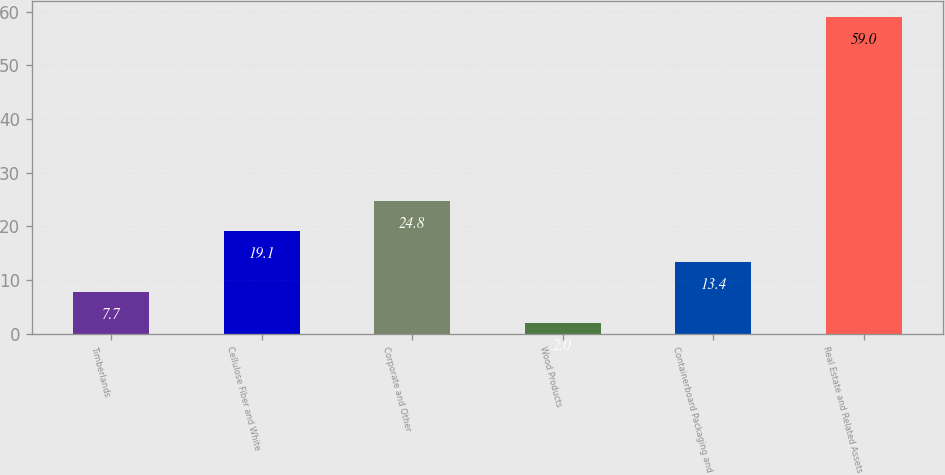Convert chart. <chart><loc_0><loc_0><loc_500><loc_500><bar_chart><fcel>Timberlands<fcel>Cellulose Fiber and White<fcel>Corporate and Other<fcel>Wood Products<fcel>Containerboard Packaging and<fcel>Real Estate and Related Assets<nl><fcel>7.7<fcel>19.1<fcel>24.8<fcel>2<fcel>13.4<fcel>59<nl></chart> 